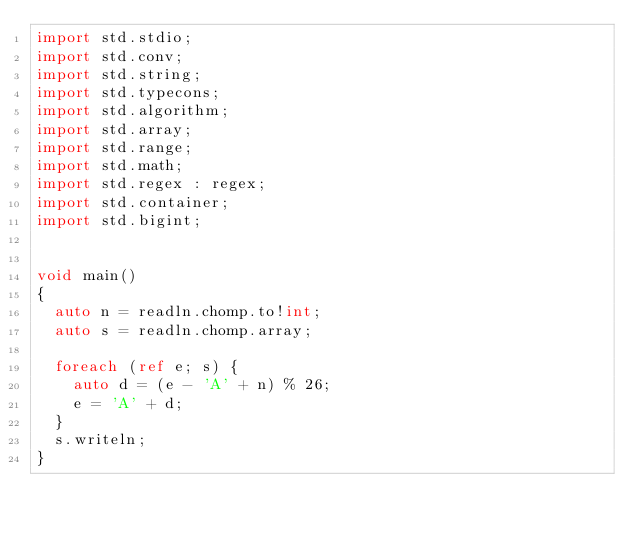<code> <loc_0><loc_0><loc_500><loc_500><_D_>import std.stdio;
import std.conv;
import std.string;
import std.typecons;
import std.algorithm;
import std.array;
import std.range;
import std.math;
import std.regex : regex;
import std.container;
import std.bigint;


void main()
{
  auto n = readln.chomp.to!int;
  auto s = readln.chomp.array;
  
  foreach (ref e; s) {
    auto d = (e - 'A' + n) % 26;
    e = 'A' + d;
  }
  s.writeln;
}
</code> 